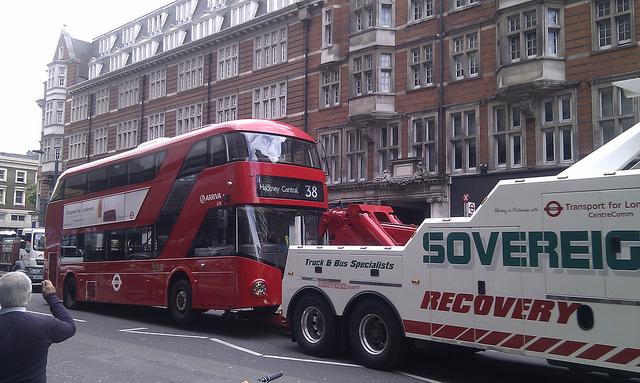Is the building made of brick?
Keep it brief. Yes. What vehicle is in front?
Concise answer only. Tow truck. What is the number on the bus?
Answer briefly. 38. 